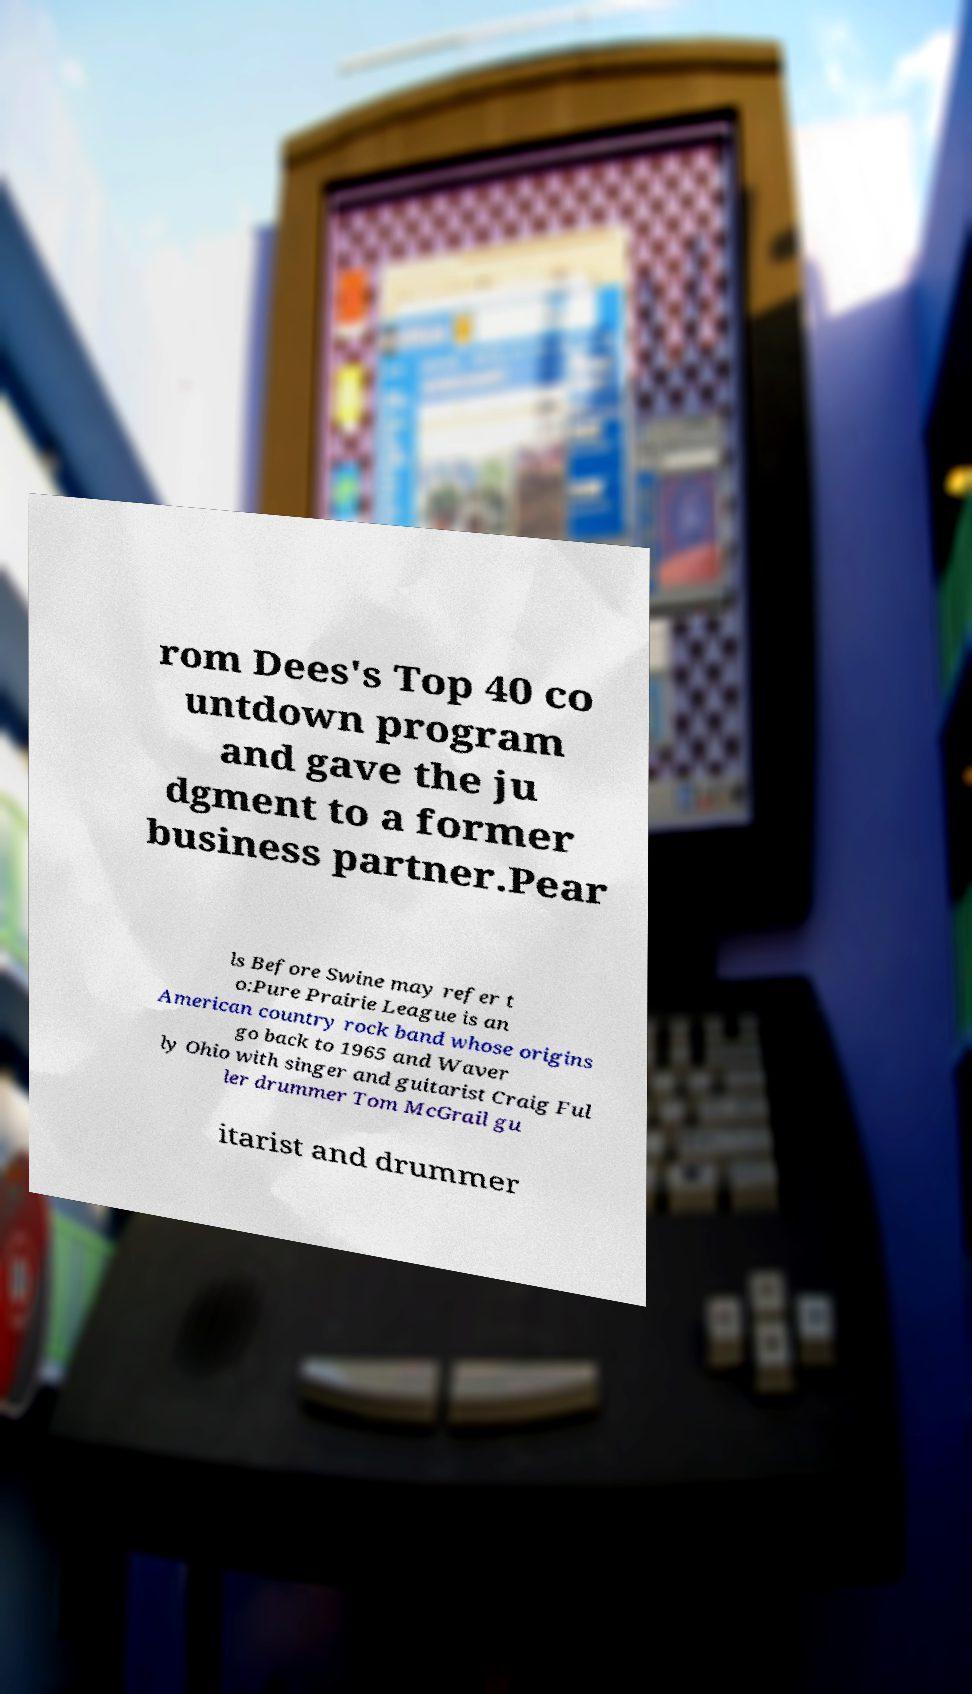Can you accurately transcribe the text from the provided image for me? rom Dees's Top 40 co untdown program and gave the ju dgment to a former business partner.Pear ls Before Swine may refer t o:Pure Prairie League is an American country rock band whose origins go back to 1965 and Waver ly Ohio with singer and guitarist Craig Ful ler drummer Tom McGrail gu itarist and drummer 